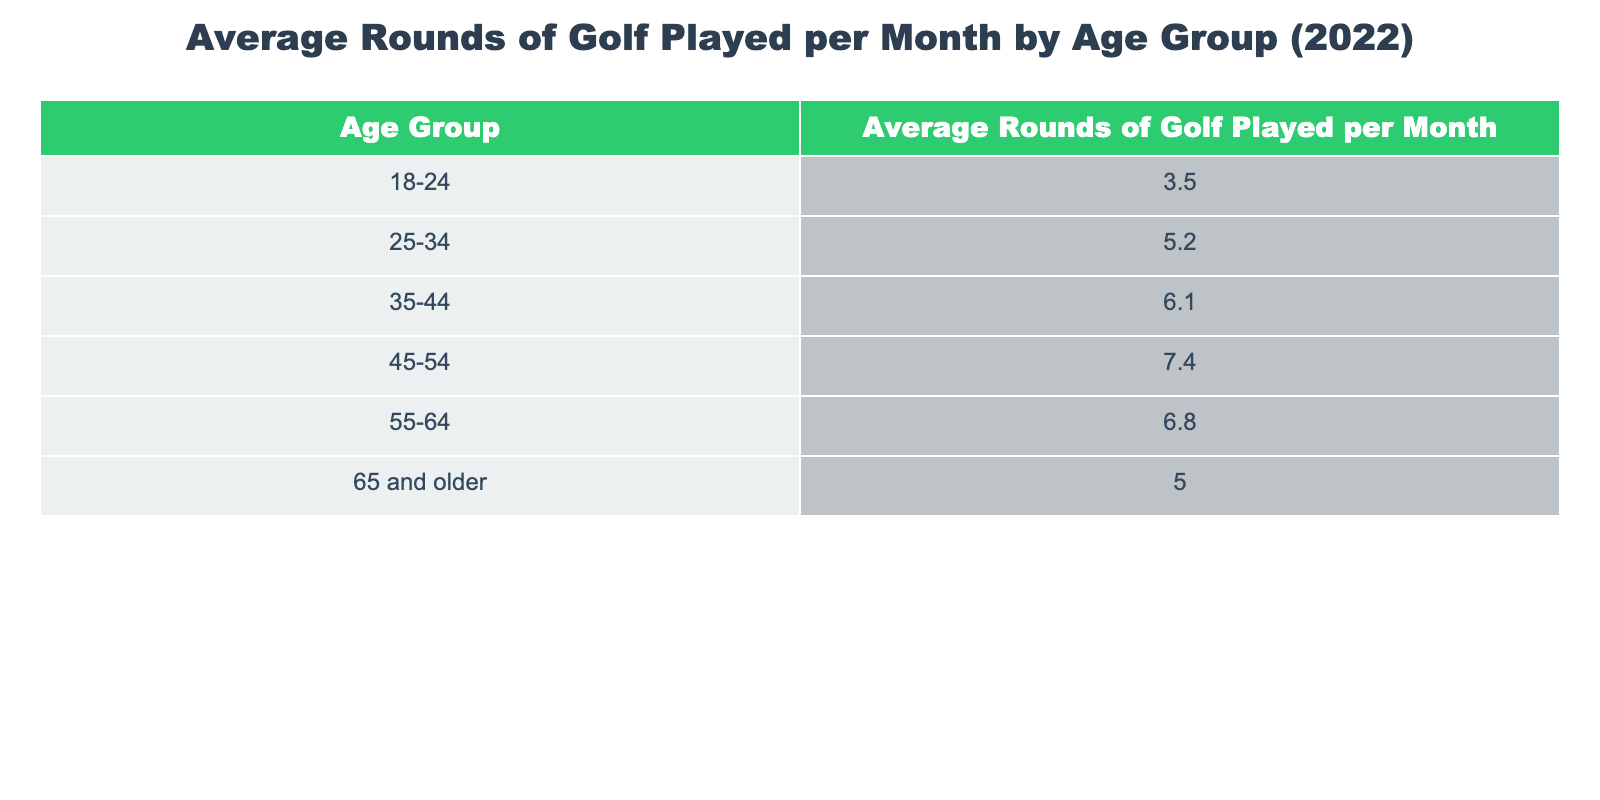What is the average number of rounds played per month by individuals aged 35-44? The table shows that the average rounds of golf played per month by the 35-44 age group is directly listed. Referring to the table, the average is noted as 6.1.
Answer: 6.1 How many rounds do individuals aged 45-54 play on average per month? From the table, we can see the average number of rounds played per month for the 45-54 age group is explicitly stated as 7.4.
Answer: 7.4 What is the total average number of rounds played per month by all age groups listed? To find the total average number of rounds played, we need to sum the averages from all the age groups: 3.5 + 5.2 + 6.1 + 7.4 + 6.8 + 5.0 = 33.0. Then, we divide by the number of age groups (6). Thus, the average is 33.0 / 6 = 5.5.
Answer: 5.5 Is the average number of rounds played by those aged 25-34 greater than that played by those aged 65 and older? The table shows that individuals aged 25-34 play an average of 5.2 rounds, while those aged 65 and older play an average of 5.0 rounds. Here, 5.2 is greater than 5.0, confirming the statement is true.
Answer: Yes What is the difference in average rounds played per month between the youngest (18-24) and the oldest age group (65 and older)? To find the difference, we subtract the average for the 65 and older age group (5.0) from that of the 18-24 age group (3.5): 3.5 - 5.0 = -1.5. The negative value indicates that those aged 18-24 play fewer rounds than those 65 and older by 1.5 rounds.
Answer: -1.5 Do individuals aged 55-64 play more rounds on average than those aged 35-44? Looking at the average for the 55-64 age group, which is 6.8, and comparing it with the 35-44 age group, which averages 6.1, we see that 6.8 is greater than 6.1, hence the statement is true.
Answer: Yes What age group has the highest average number of rounds played per month? From the table, the highest average is for the 45-54 age group at 7.4. By scanning through the averages of each group, this is confirmed as the maximum value.
Answer: 45-54 What would the average rounds per month be if the 55-64 age group's number decreased by 1? If the average for the 55-64 age group decreases from 6.8 to 5.8, we recalculate the total average: (3.5 + 5.2 + 6.1 + 7.4 + 5.8 + 5.0) = 33.0. Dividing by 6 gives us an average of 33.0 / 6 = 5.5, which remains unchanged from the previous total average.
Answer: 5.5 